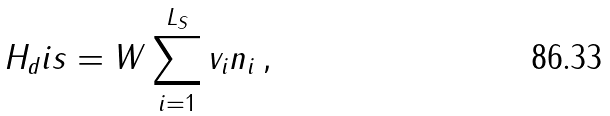<formula> <loc_0><loc_0><loc_500><loc_500>H _ { d } i s = W \sum _ { i = 1 } ^ { L _ { S } } v _ { i } n _ { i } \, ,</formula> 